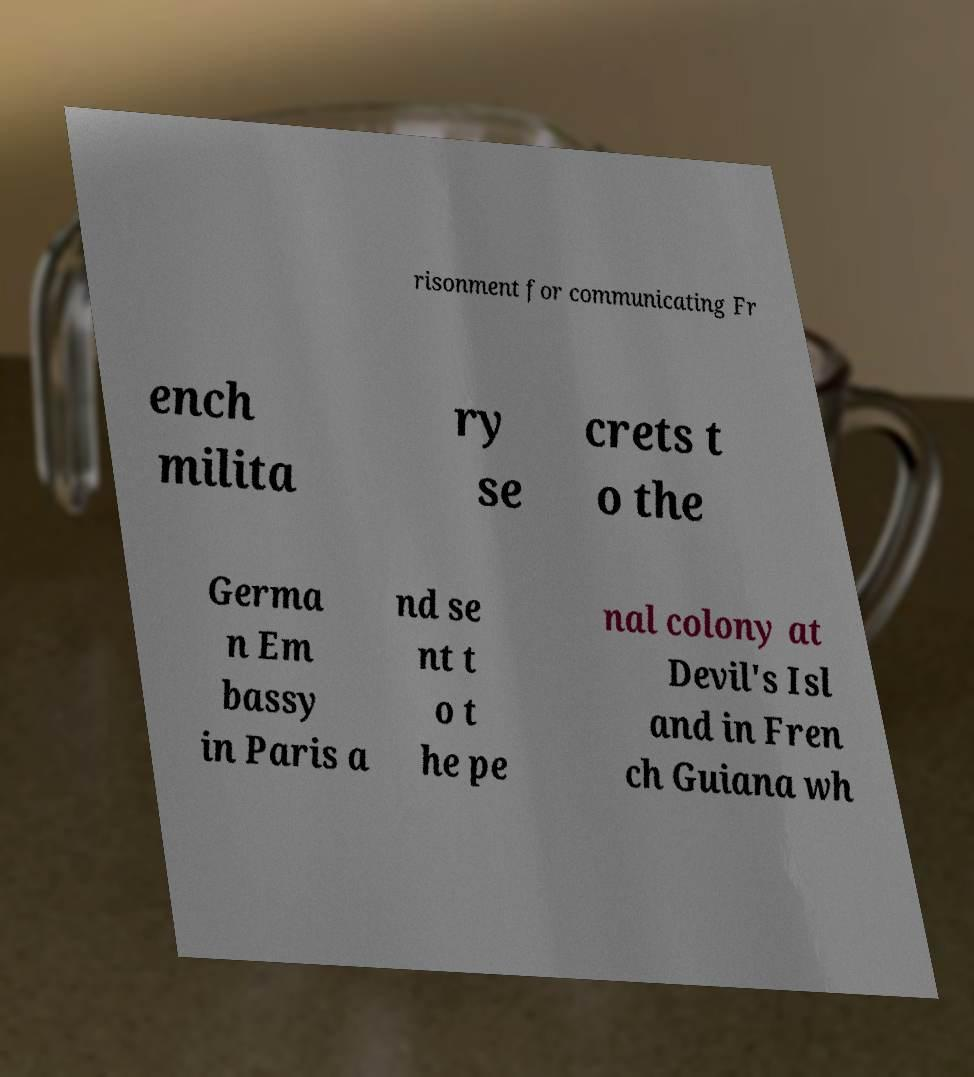There's text embedded in this image that I need extracted. Can you transcribe it verbatim? risonment for communicating Fr ench milita ry se crets t o the Germa n Em bassy in Paris a nd se nt t o t he pe nal colony at Devil's Isl and in Fren ch Guiana wh 